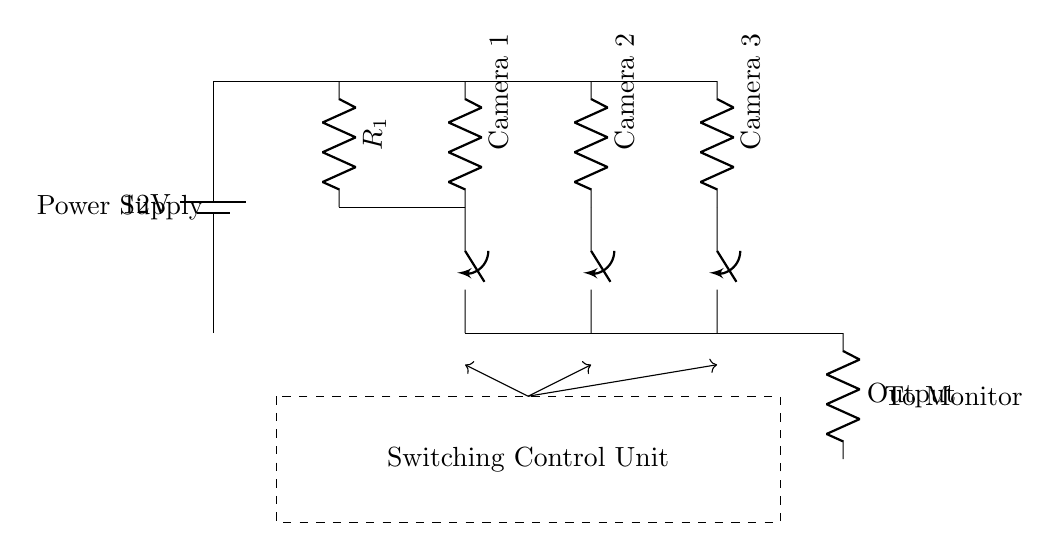What is the power supply voltage for this circuit? The main power supply is indicated as a battery with a voltage label of twelve volts, confirming the circuit operates at this potential difference.
Answer: 12 volts What components are connected to the power supply? The circuit shows a battery connected to a resistor for power distribution and three cameras, each represented as resistors. This shows that the cameras operate off the power supply.
Answer: Resistor and Cameras How many camera inputs are part of the circuit? The circuit diagram clearly depicts three camera inputs connected parallelly to the power distribution network.
Answer: Three What is the purpose of the switching control unit? The switching control unit acts as the mechanism to manage which camera input is connected to the output stage, facilitating seamless switching between the cameras for monitoring.
Answer: To switch camera inputs If all cameras are active, what current would flow through the output resistor? Assuming each camera draws the same current and using Ohm's law with the provided voltage and general resistive load analysis, the output current would be equivalent to the total current from the three parallel camera circuits, which mathematically involves knowing the resistance values of each camera. As the specific values are not provided, a numerical answer cannot be determined from the given data.
Answer: Indeterminate What type of circuit configuration is used for the camera connections? The cameras are connected in parallel to the power supply, allowing for independent operation and switching while maintaining the same voltage across each connection.
Answer: Parallel 